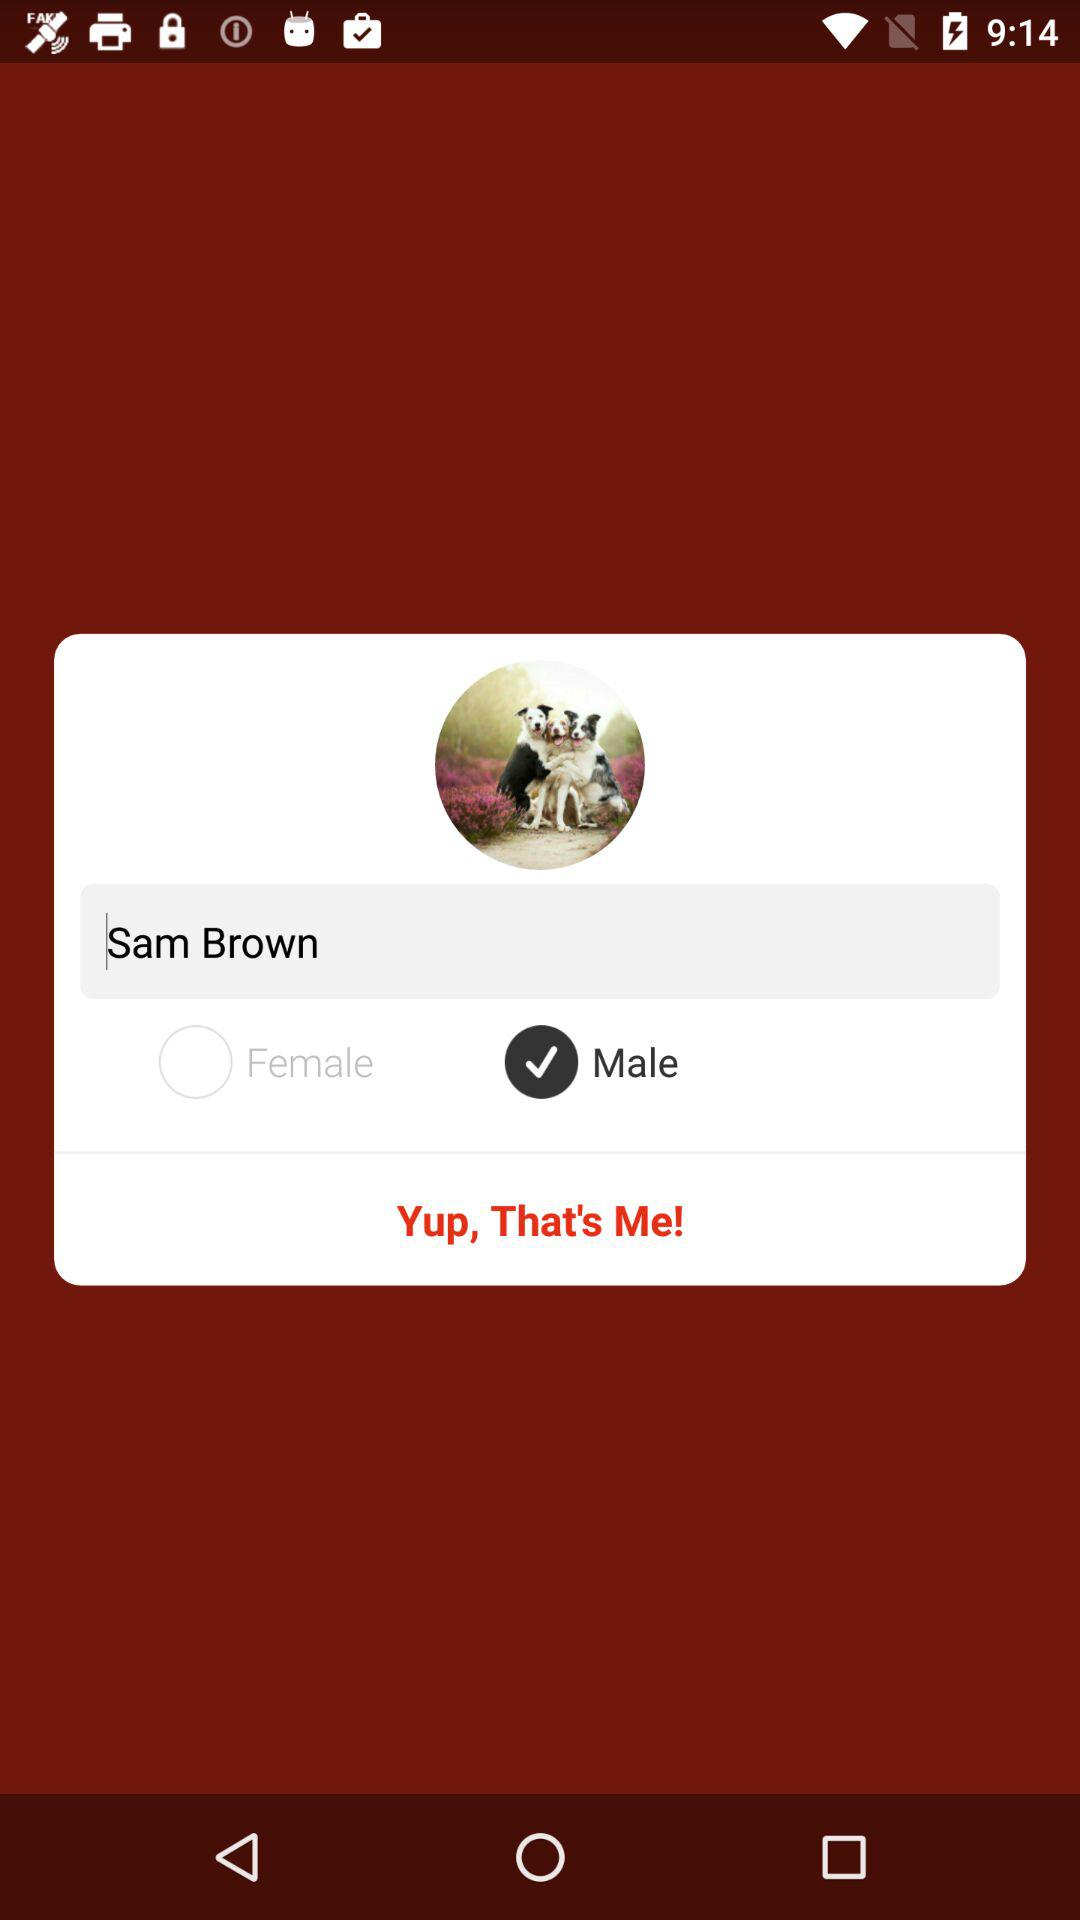What is the name? The name is Sam Brown. 